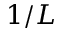Convert formula to latex. <formula><loc_0><loc_0><loc_500><loc_500>1 / L</formula> 